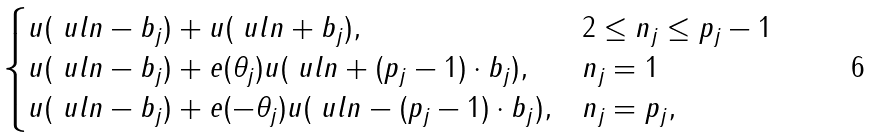Convert formula to latex. <formula><loc_0><loc_0><loc_500><loc_500>\begin{cases} u ( \ u l { n } - b _ { j } ) + u ( \ u l { n } + b _ { j } ) , & 2 \leq n _ { j } \leq p _ { j } - 1 \\ u ( \ u l { n } - b _ { j } ) + e ( \theta _ { j } ) u ( \ u l { n } + ( p _ { j } - 1 ) \cdot b _ { j } ) , & n _ { j } = 1 \\ u ( \ u l { n } - b _ { j } ) + e ( - \theta _ { j } ) u ( \ u l { n } - ( p _ { j } - 1 ) \cdot b _ { j } ) , & n _ { j } = p _ { j } , \end{cases}</formula> 